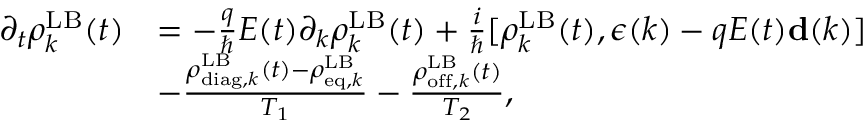Convert formula to latex. <formula><loc_0><loc_0><loc_500><loc_500>\begin{array} { r l } { \partial _ { t } \rho _ { k } ^ { L B } ( t ) } & { = - \frac { q } { } E ( t ) \partial _ { k } \rho _ { k } ^ { L B } ( t ) + \frac { i } { } [ \rho _ { k } ^ { L B } ( t ) , { \boldsymbol \epsilon } ( k ) - q E ( t ) { d } ( k ) ] } \\ & { - \frac { \rho _ { d i a g , k } ^ { L B } ( t ) - \rho _ { e q , k } ^ { L B } } { T _ { 1 } } - \frac { \rho _ { o f f , k } ^ { L B } ( t ) } { T _ { 2 } } , } \end{array}</formula> 